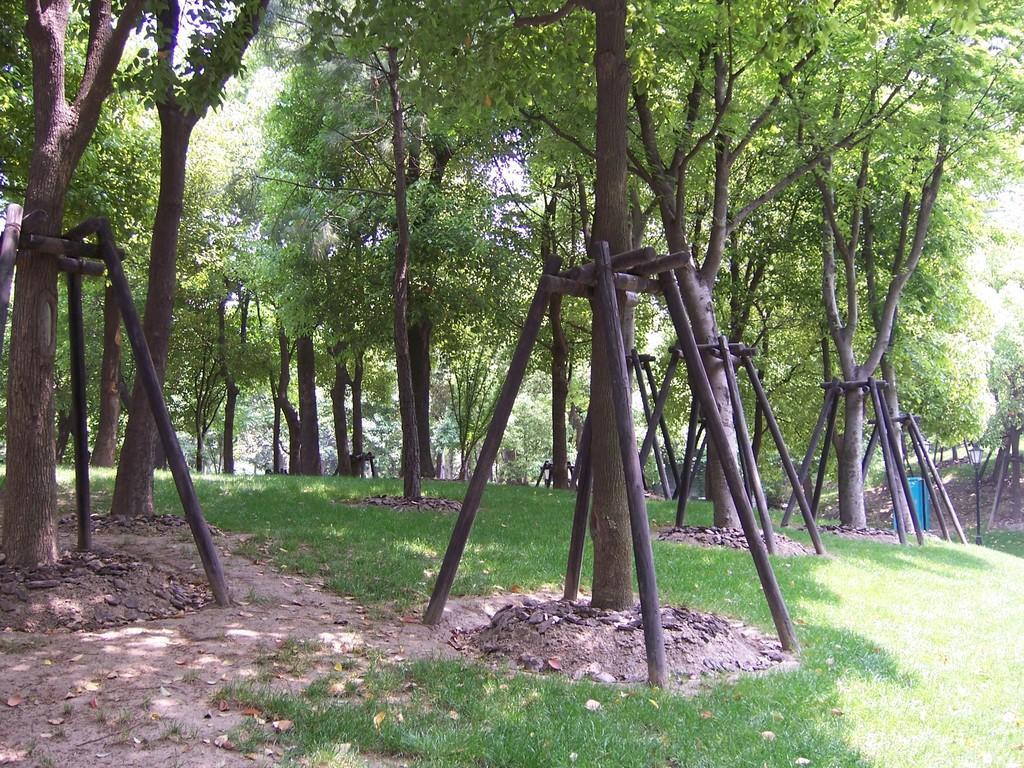What type of vegetation can be seen in the image? There are trees in the image. What structures are present in the image? There are wooden stands in the image. What type of door can be seen on the wooden stand in the image? There is no door present on the wooden stands in the image. What invention is being demonstrated by the trees in the image? The trees in the image are not demonstrating any invention; they are simply trees. 